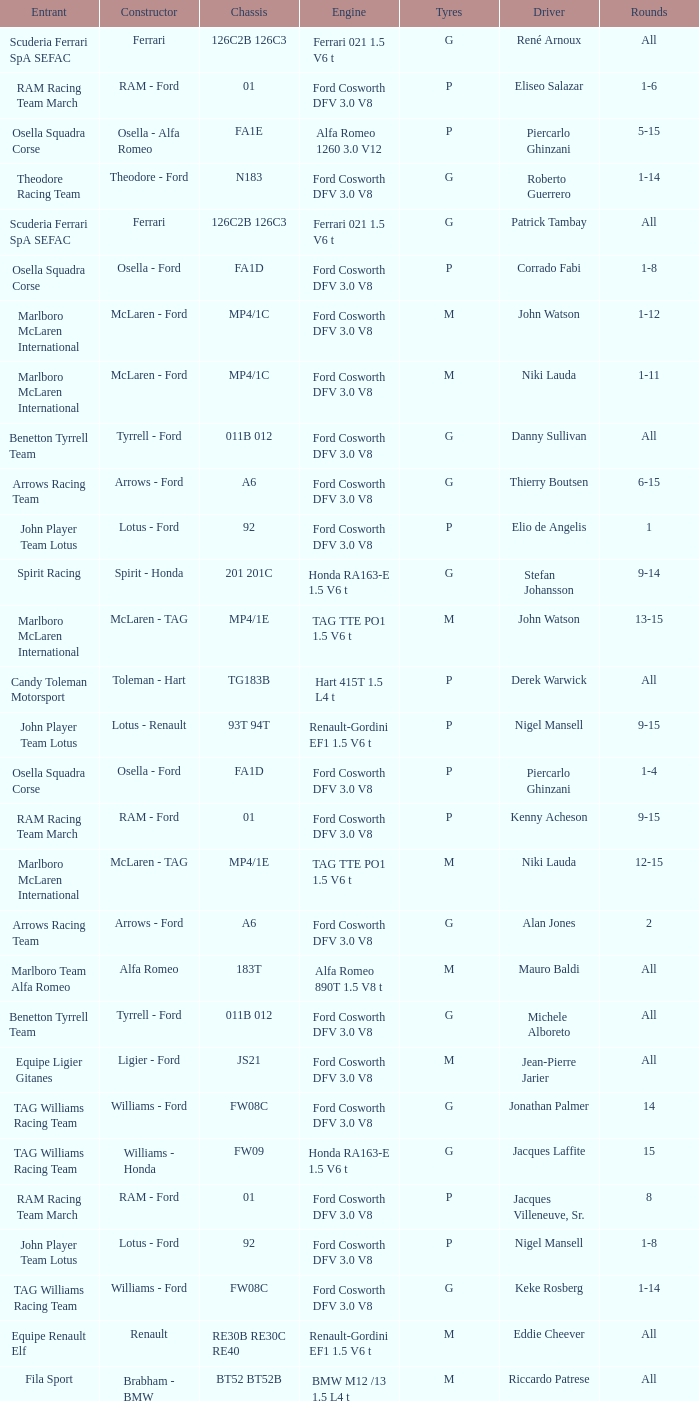Who is driver of the d6 chassis? Manfred Winkelhock. 